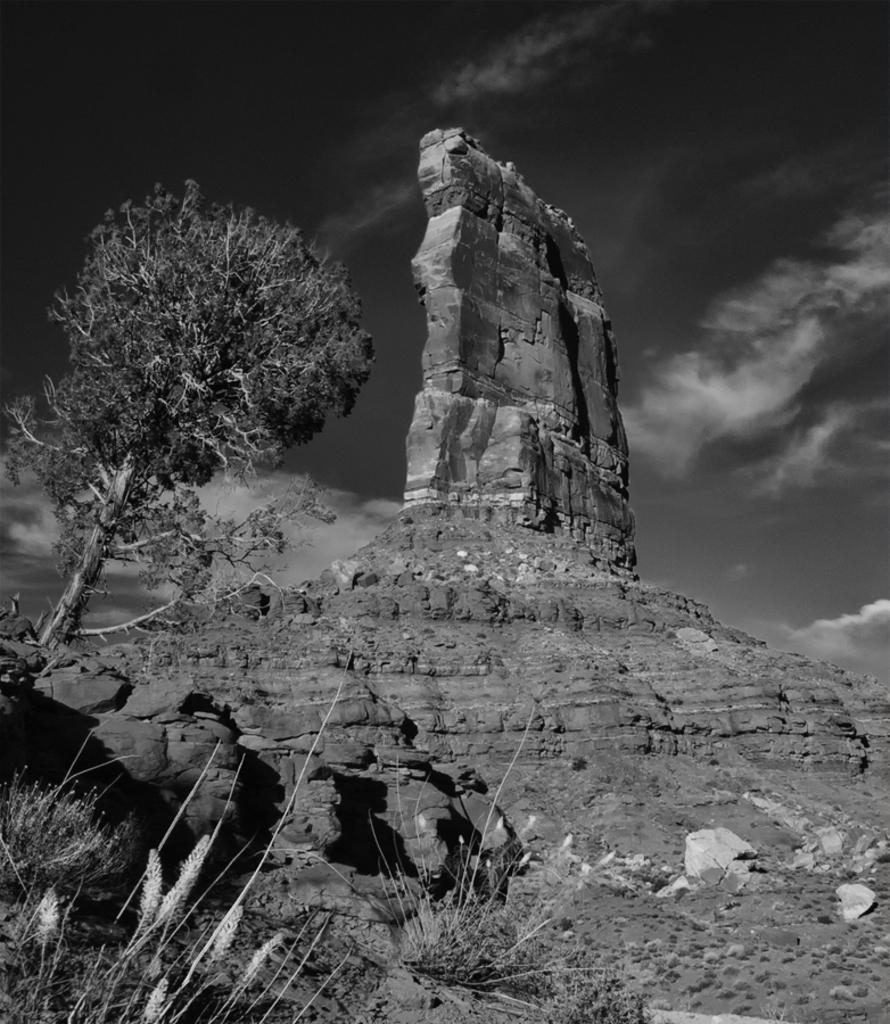What is the color scheme of the image? The image is black and white. What geographical feature can be seen in the image? There is a hill in the image. What type of objects are present in the image? There are stones and plants in the image. What type of vegetation is present in the image? There is a tree in the image. What part of the natural environment is visible in the image? The sky is visible in the image. What is the weather condition in the image? The sky appears cloudy in the image. What type of grain can be seen growing on the hill in the image? There is no grain visible in the image; it only features a hill, stones, plants, a tree, and a cloudy sky. 